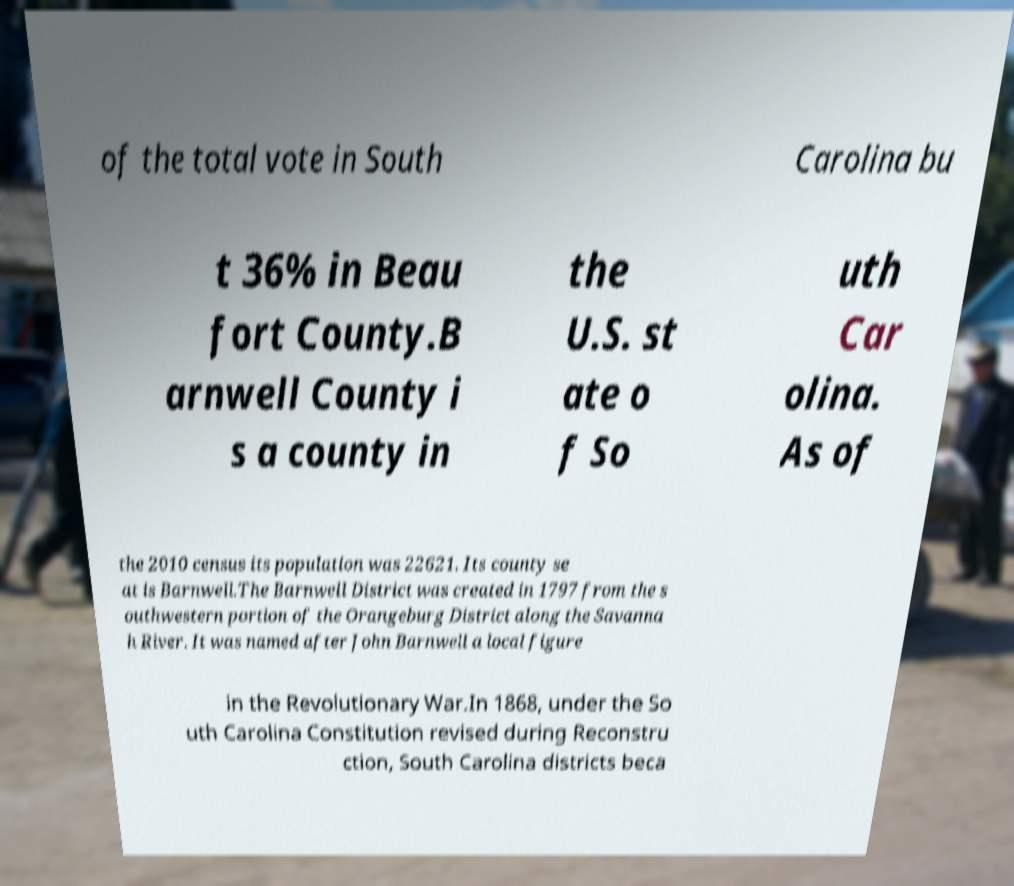Could you extract and type out the text from this image? of the total vote in South Carolina bu t 36% in Beau fort County.B arnwell County i s a county in the U.S. st ate o f So uth Car olina. As of the 2010 census its population was 22621. Its county se at is Barnwell.The Barnwell District was created in 1797 from the s outhwestern portion of the Orangeburg District along the Savanna h River. It was named after John Barnwell a local figure in the Revolutionary War.In 1868, under the So uth Carolina Constitution revised during Reconstru ction, South Carolina districts beca 